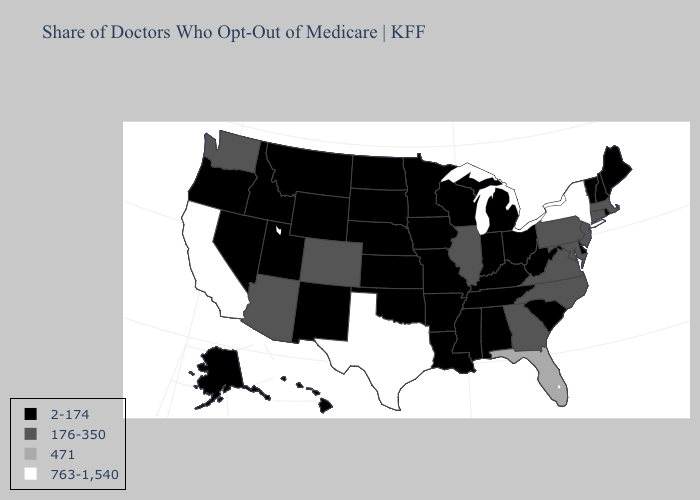Name the states that have a value in the range 176-350?
Answer briefly. Arizona, Colorado, Connecticut, Georgia, Illinois, Maryland, Massachusetts, New Jersey, North Carolina, Pennsylvania, Virginia, Washington. What is the highest value in the Northeast ?
Give a very brief answer. 763-1,540. Name the states that have a value in the range 471?
Quick response, please. Florida. Name the states that have a value in the range 763-1,540?
Keep it brief. California, New York, Texas. What is the lowest value in the USA?
Be succinct. 2-174. What is the value of North Dakota?
Keep it brief. 2-174. What is the highest value in the USA?
Concise answer only. 763-1,540. What is the value of Oklahoma?
Answer briefly. 2-174. Name the states that have a value in the range 2-174?
Quick response, please. Alabama, Alaska, Arkansas, Delaware, Hawaii, Idaho, Indiana, Iowa, Kansas, Kentucky, Louisiana, Maine, Michigan, Minnesota, Mississippi, Missouri, Montana, Nebraska, Nevada, New Hampshire, New Mexico, North Dakota, Ohio, Oklahoma, Oregon, Rhode Island, South Carolina, South Dakota, Tennessee, Utah, Vermont, West Virginia, Wisconsin, Wyoming. Name the states that have a value in the range 2-174?
Keep it brief. Alabama, Alaska, Arkansas, Delaware, Hawaii, Idaho, Indiana, Iowa, Kansas, Kentucky, Louisiana, Maine, Michigan, Minnesota, Mississippi, Missouri, Montana, Nebraska, Nevada, New Hampshire, New Mexico, North Dakota, Ohio, Oklahoma, Oregon, Rhode Island, South Carolina, South Dakota, Tennessee, Utah, Vermont, West Virginia, Wisconsin, Wyoming. Among the states that border Washington , which have the highest value?
Give a very brief answer. Idaho, Oregon. Among the states that border Utah , which have the lowest value?
Give a very brief answer. Idaho, Nevada, New Mexico, Wyoming. Name the states that have a value in the range 2-174?
Quick response, please. Alabama, Alaska, Arkansas, Delaware, Hawaii, Idaho, Indiana, Iowa, Kansas, Kentucky, Louisiana, Maine, Michigan, Minnesota, Mississippi, Missouri, Montana, Nebraska, Nevada, New Hampshire, New Mexico, North Dakota, Ohio, Oklahoma, Oregon, Rhode Island, South Carolina, South Dakota, Tennessee, Utah, Vermont, West Virginia, Wisconsin, Wyoming. Name the states that have a value in the range 763-1,540?
Short answer required. California, New York, Texas. 